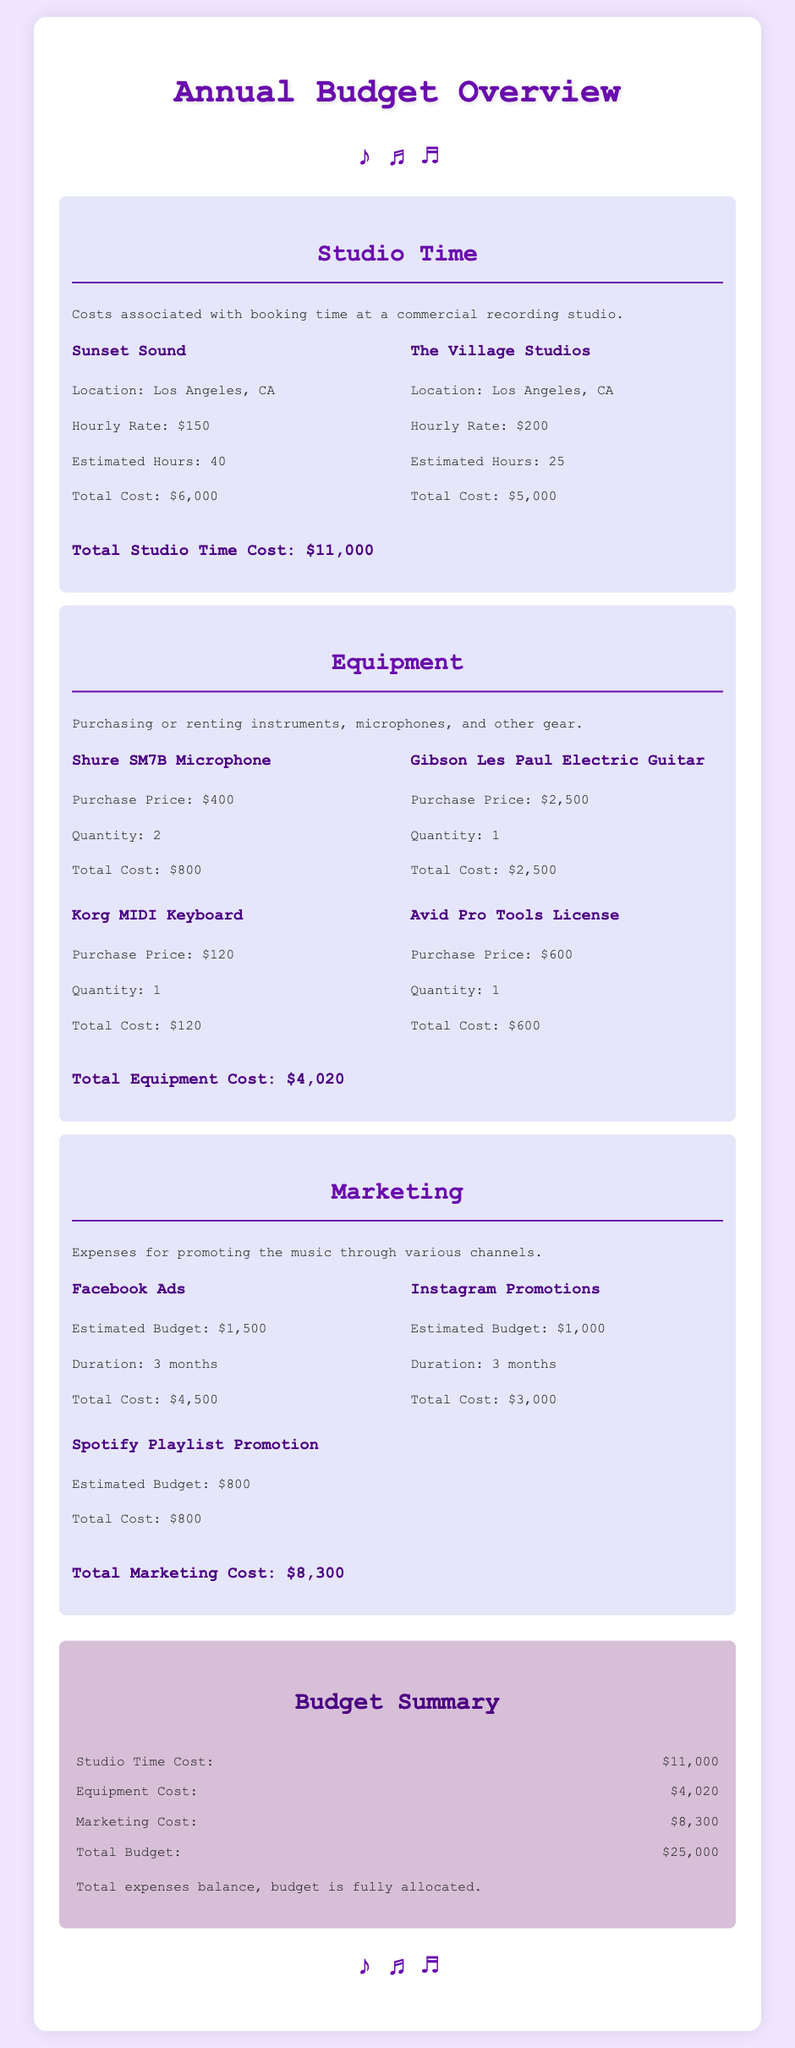What is the total cost for studio time? The total cost for studio time is the sum of the costs for both studio bookings detailed in the document, which is $6,000 + $5,000.
Answer: $11,000 How much does the Gibson Les Paul Electric Guitar cost? The document lists the purchase price of the Gibson Les Paul Electric Guitar as $2,500.
Answer: $2,500 What is the estimated budget for Facebook Ads? The estimated budget for Facebook Ads is given as $1,500, which is mentioned before the total cost.
Answer: $1,500 How many Shure SM7B microphones were purchased? The document indicates that 2 Shure SM7B microphones were purchased.
Answer: 2 What is the total marketing cost? The total marketing cost is the sum of all marketing expenses detailed in the document, which amounts to $4,500 + $3,000 + $800.
Answer: $8,300 What is the total budget allocated for expenses? The total budget allocated for expenses is stated in the summary section of the document.
Answer: $25,000 What is the hourly rate for Sunset Sound? The document specifies the hourly rate for Sunset Sound as $150.
Answer: $150 What type of license is included in the equipment section? The equipment section includes an Avid Pro Tools License, as mentioned in the detailed list.
Answer: Avid Pro Tools License 